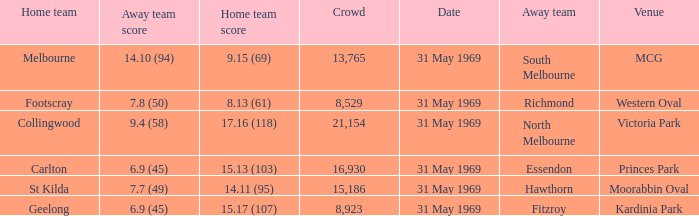What was the highest crowd in Victoria Park? 21154.0. 